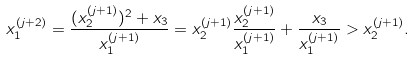Convert formula to latex. <formula><loc_0><loc_0><loc_500><loc_500>x _ { 1 } ^ { ( j + 2 ) } = \frac { ( x _ { 2 } ^ { ( j + 1 ) } ) ^ { 2 } + x _ { 3 } } { x _ { 1 } ^ { ( j + 1 ) } } = x _ { 2 } ^ { ( j + 1 ) } \frac { x _ { 2 } ^ { ( j + 1 ) } } { x _ { 1 } ^ { ( j + 1 ) } } + \frac { x _ { 3 } } { x _ { 1 } ^ { ( j + 1 ) } } > x _ { 2 } ^ { ( j + 1 ) } .</formula> 